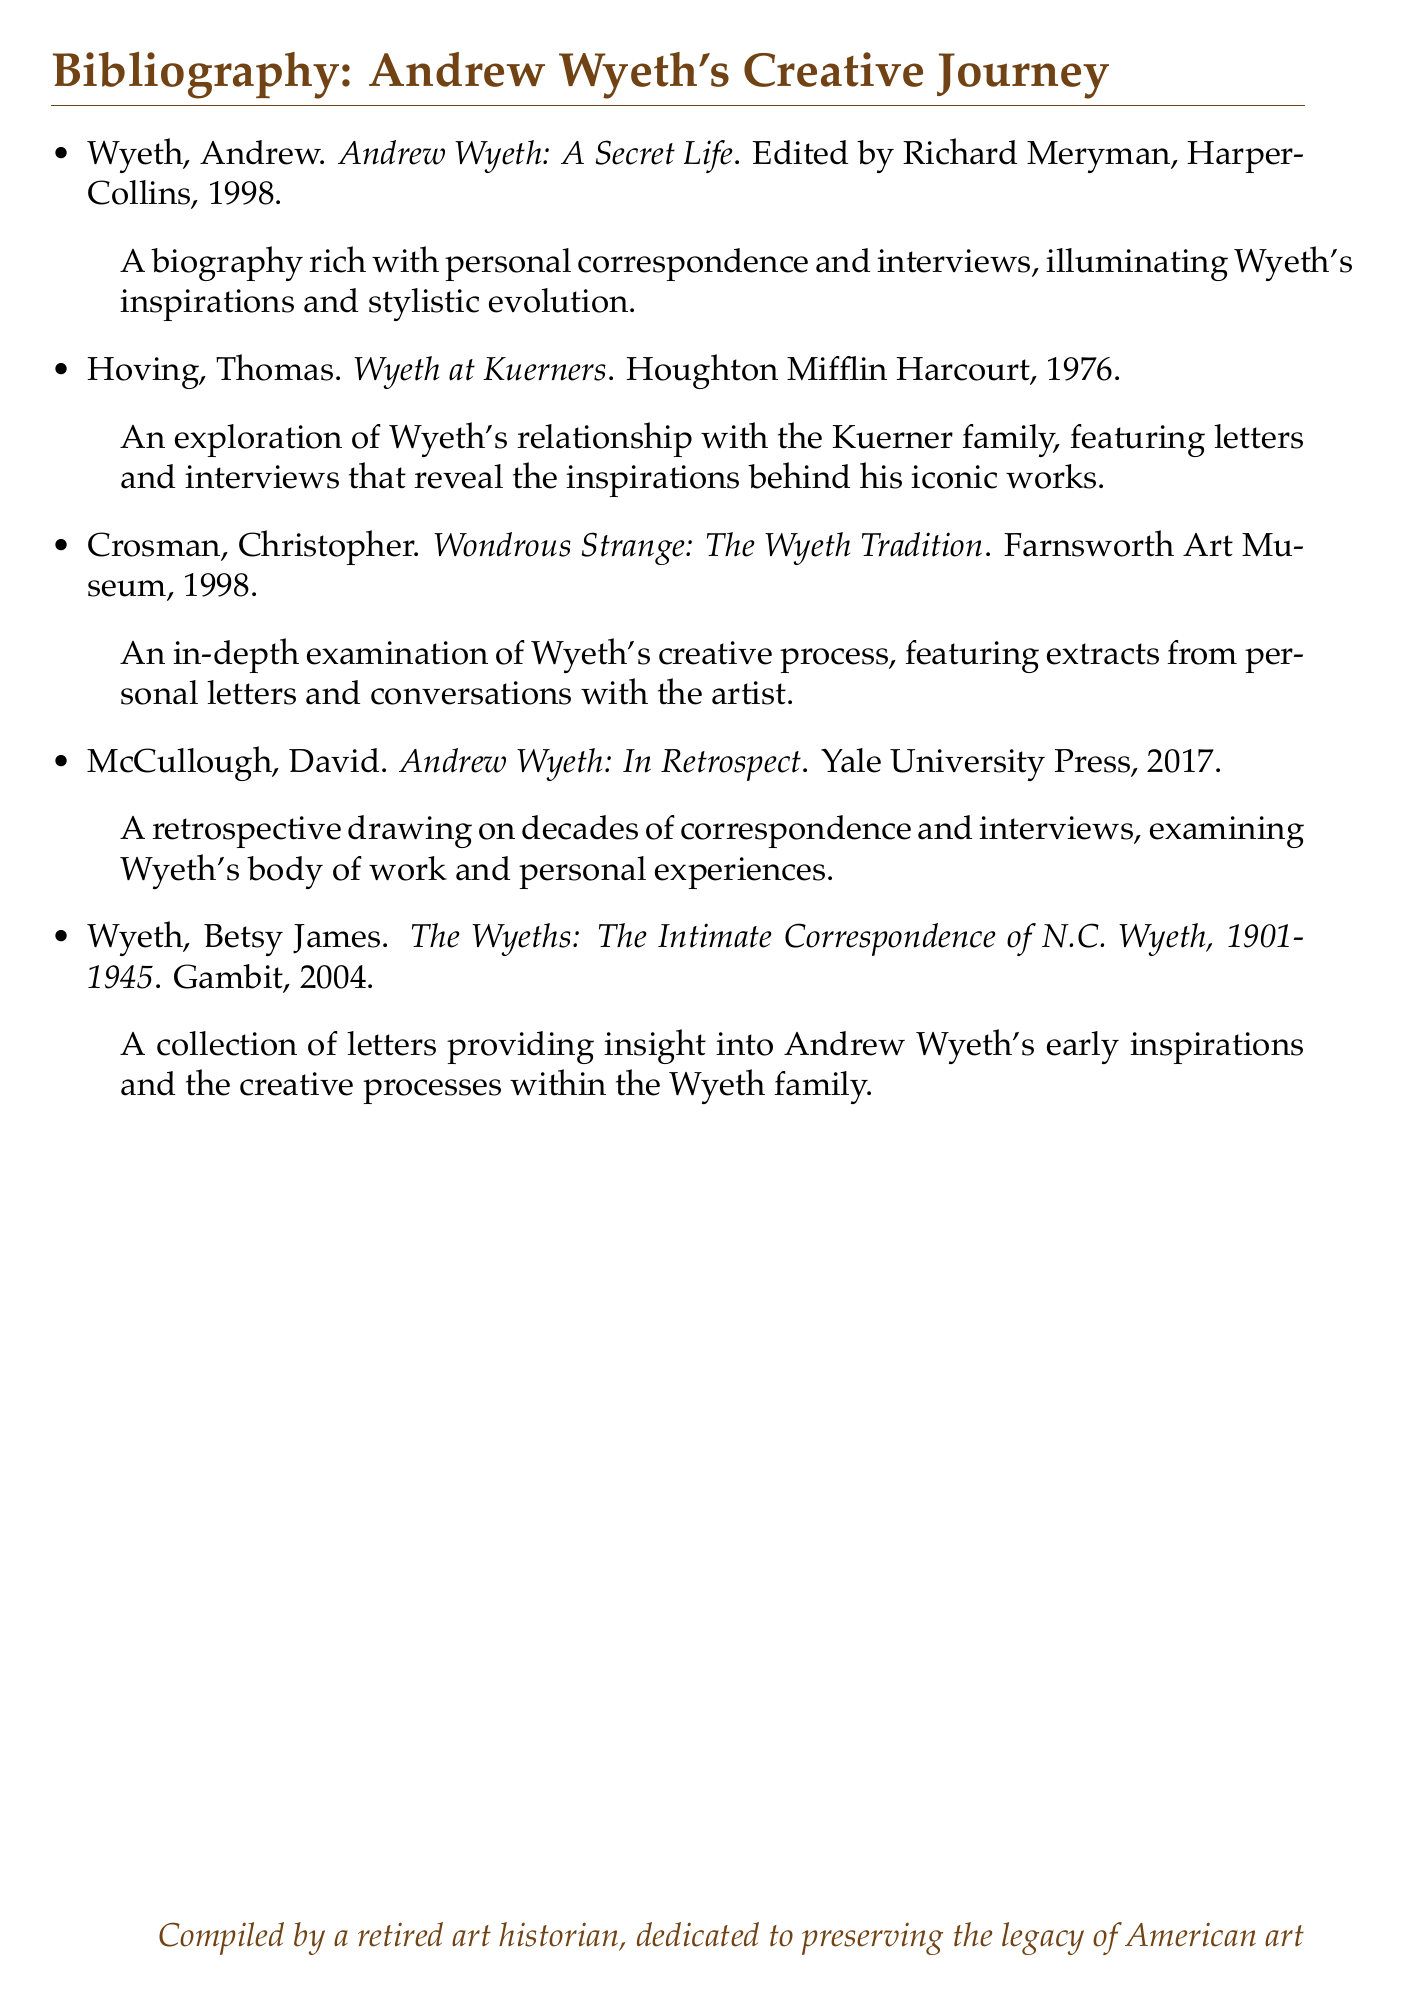What is the title of the biography edited by Richard Meryman? The title is listed in the bibliography and provides information about Wyeth's life and work.
Answer: Andrew Wyeth: A Secret Life Who authored "Wyeth at Kuerners"? The author of this book is Thomas Hoving, which is stated in the bibliography.
Answer: Thomas Hoving What year was "Andrew Wyeth: In Retrospect" published? The publication year is found in the description of the bibliography entry for this book.
Answer: 2017 How many works does this bibliography include? The total number of works listed in the bibliography can be counted directly.
Answer: Five Which book focuses on the intimate correspondence of N.C. Wyeth? This book title appears in the bibliography and relates to the early influences within the Wyeth family.
Answer: The Wyeths: The Intimate Correspondence of N.C. Wyeth, 1901-1945 What type of insights does "Wondrous Strange: The Wyeth Tradition" examine? This detail is explicitly mentioned in the description of the bibliography entry.
Answer: Creative process Who is the compiler of this bibliography? The compiler's name is noted in the closing statement of the document.
Answer: A retired art historian 